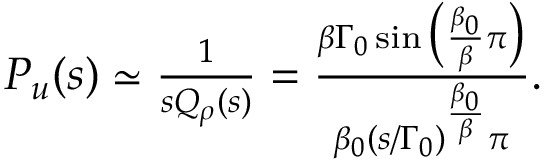Convert formula to latex. <formula><loc_0><loc_0><loc_500><loc_500>\begin{array} { r } { { P } _ { u } ( s ) \simeq \frac { 1 } { s Q _ { \rho } ( s ) } = \frac { \beta \Gamma _ { 0 } \sin \left ( \frac { \beta _ { 0 } } { \beta } \pi \right ) } { \beta _ { 0 } ( s / \Gamma _ { 0 } ) ^ { \frac { \beta _ { 0 } } { \beta } } \pi } . } \end{array}</formula> 